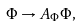Convert formula to latex. <formula><loc_0><loc_0><loc_500><loc_500>\Phi \rightarrow A _ { \Phi } \Phi ,</formula> 